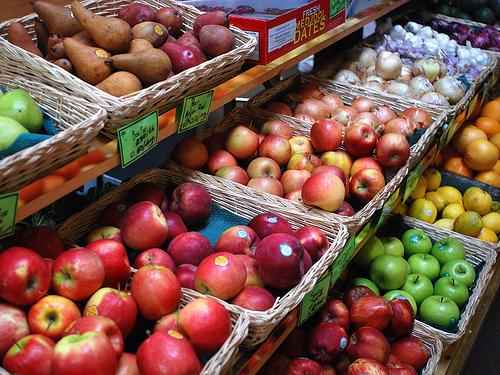Are there more red or green apples?
Quick response, please. Red. What are these fruits and vegetables called?
Give a very brief answer. Apples. Are there any dates?
Keep it brief. No. 